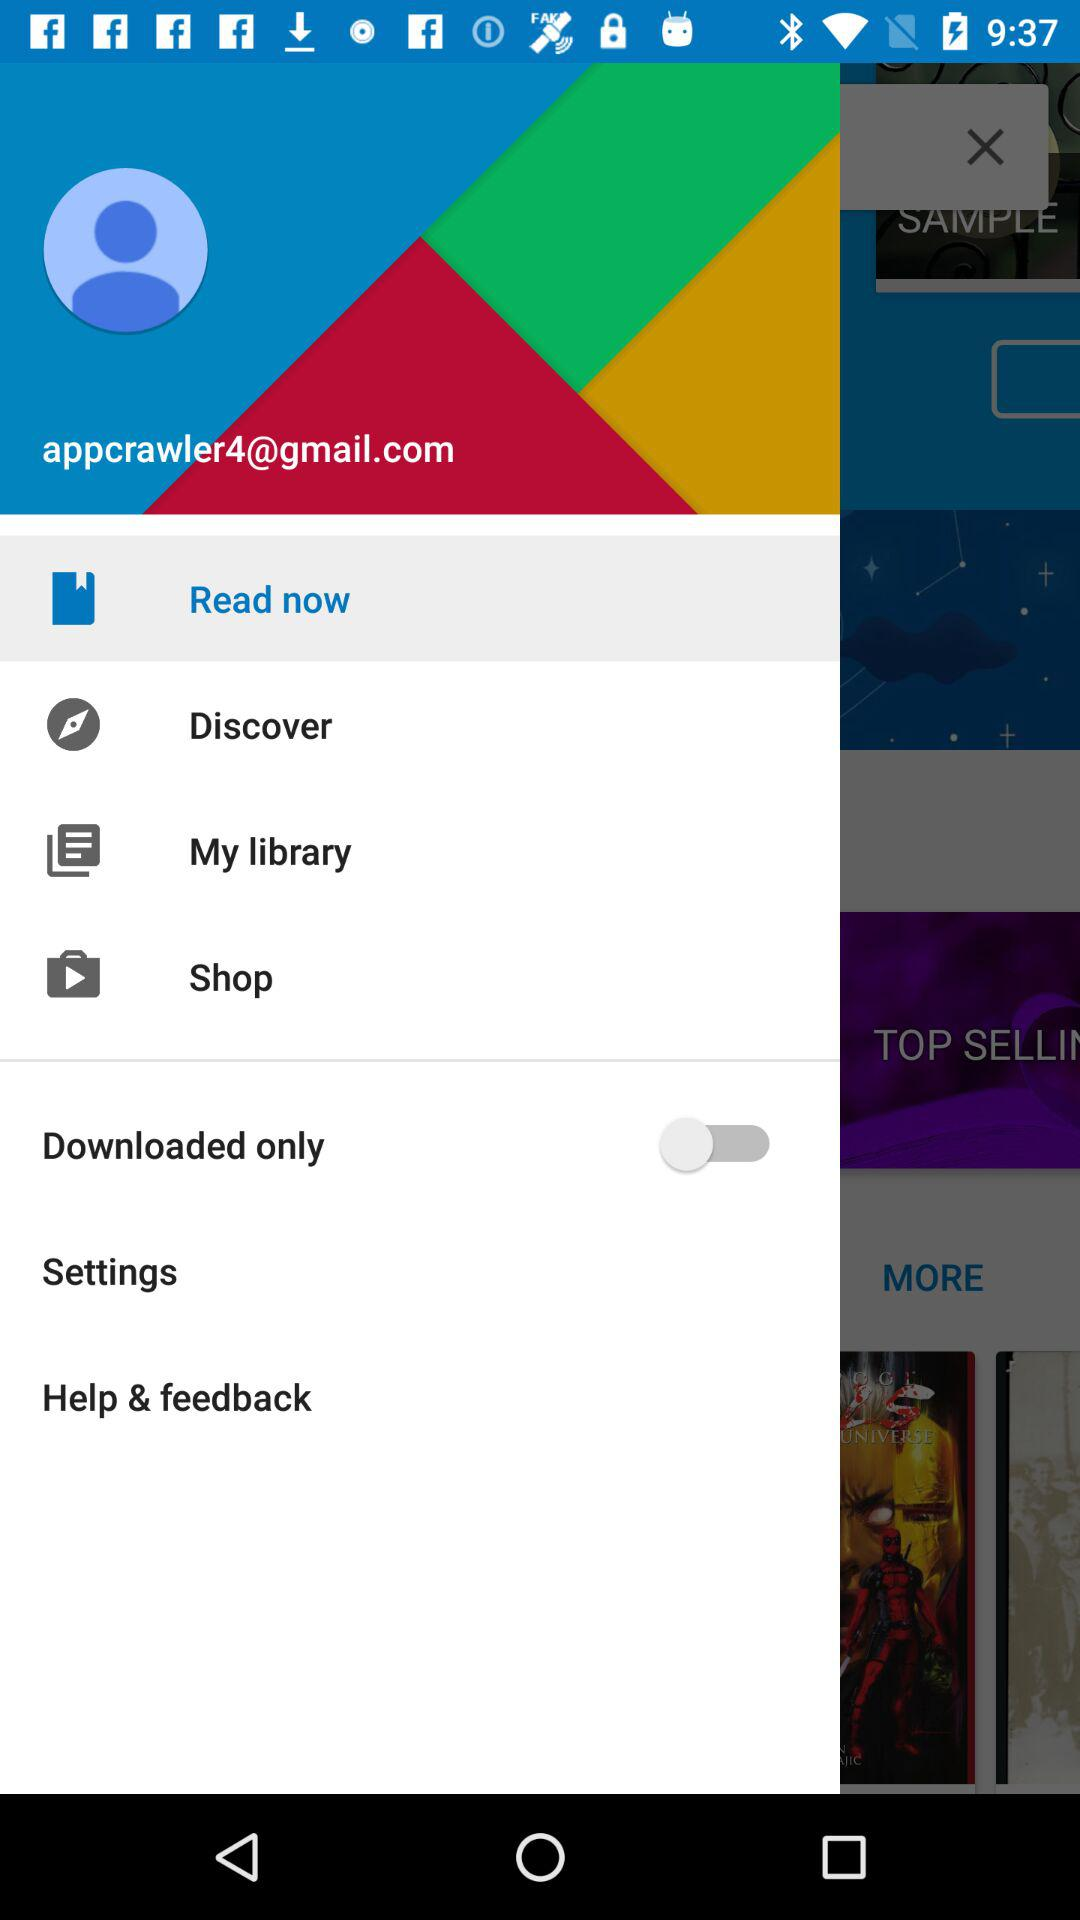What is the status of the "Download only"? The status of the "Download only" is "off". 